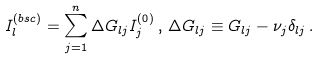Convert formula to latex. <formula><loc_0><loc_0><loc_500><loc_500>I ^ { ( b s c ) } _ { l } = \sum _ { j = 1 } ^ { n } \Delta G _ { l j } I ^ { ( 0 ) } _ { j } \, , \, \Delta G _ { l j } \equiv G _ { l j } - \nu _ { j } \delta _ { l j } \, .</formula> 